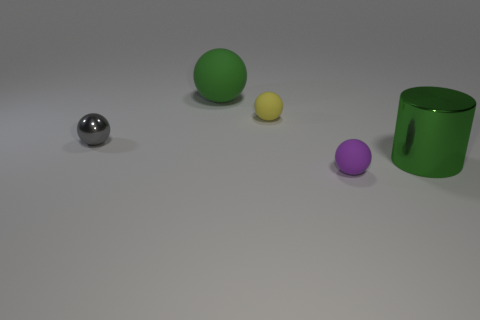How many balls have the same material as the large green cylinder?
Ensure brevity in your answer.  1. How many cylinders are either objects or green rubber things?
Make the answer very short. 1. What size is the object in front of the metal object to the right of the matte thing that is in front of the small gray ball?
Ensure brevity in your answer.  Small. The small thing that is left of the tiny purple ball and in front of the small yellow rubber ball is what color?
Make the answer very short. Gray. There is a green cylinder; is it the same size as the green sphere that is behind the yellow thing?
Provide a short and direct response. Yes. Are there any other things that are the same shape as the small purple object?
Provide a succinct answer. Yes. There is a large object that is the same shape as the small gray shiny thing; what is its color?
Provide a succinct answer. Green. Does the cylinder have the same size as the yellow sphere?
Provide a short and direct response. No. What number of other things are there of the same size as the cylinder?
Make the answer very short. 1. What number of objects are either balls that are left of the tiny yellow ball or small objects to the left of the green ball?
Give a very brief answer. 2. 